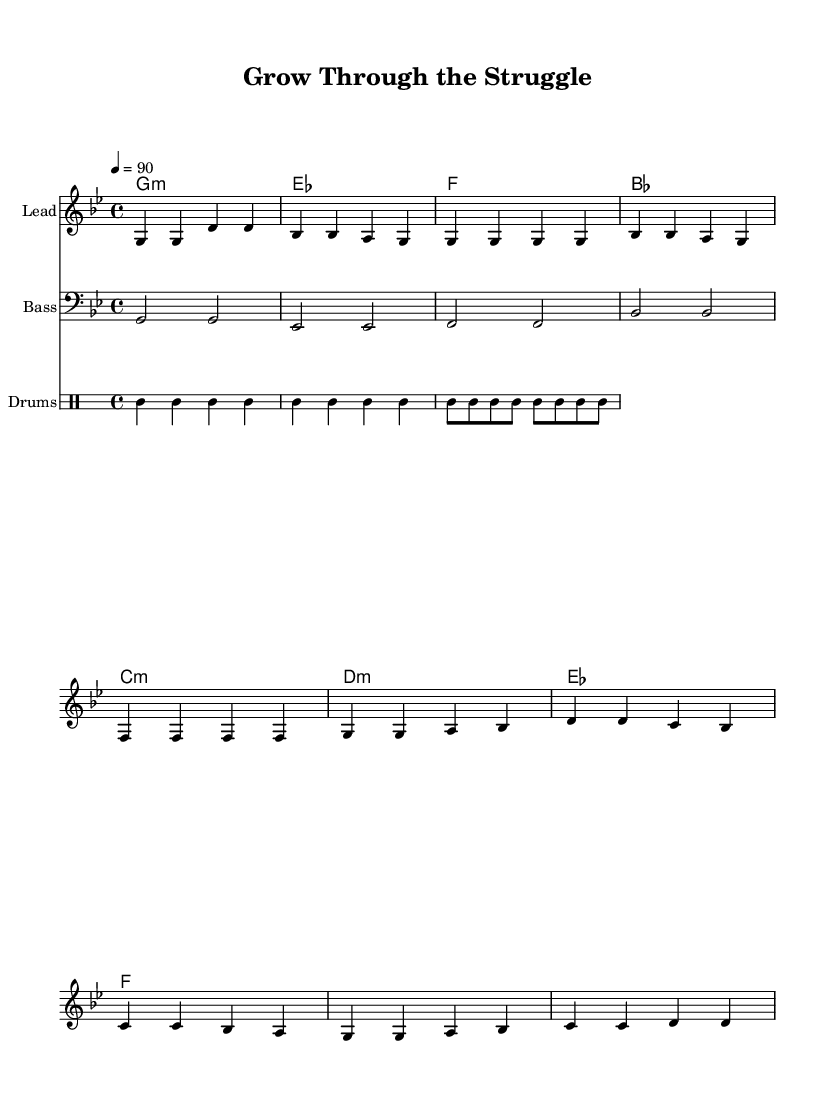What is the key signature of this music? The key signature is indicated to be G minor, which has two flats (B♭ and E♭). This can typically be identified by looking at the key signature section at the beginning of the music.
Answer: G minor What is the time signature of this music? The time signature is indicated as 4/4 at the beginning of the score, meaning there are four beats in each measure and the quarter note gets one beat.
Answer: 4/4 What is the tempo marking of this music? The tempo marking indicates a speed of 90 beats per minute, which is noted at the start of the score under the tempo directive.
Answer: 90 How many measures are in the chorus section? The chorus section comprises four measures, which can be counted visually by examining the measures marked in the score section labeled as the chorus.
Answer: 4 What is the first chord played in the piece? The first chord played is G minor. This is indicated in the harmonies section at the beginning of the score.
Answer: G minor What is the rhythmic pattern of the drum section in the first measure? The first measure of the drum section consists of four bass drum hits, which is denoted by 'bd' in the drummode. This indicates consistent quarter note rhythms played by the bass drum.
Answer: Four bass drum hits What style of music does this piece represent? The style represented is Hip Hop, which can be inferred from the structure, rhythm, and themes suggested throughout this motivational piece aimed at young farmers.
Answer: Hip Hop 